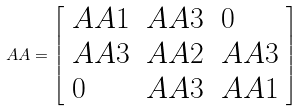<formula> <loc_0><loc_0><loc_500><loc_500>A A = { \left [ \begin{array} { l l l } { A A 1 } & { A A 3 } & { 0 } \\ { A A 3 } & { A A 2 } & { A A 3 } \\ { 0 } & { A A 3 } & { A A 1 } \end{array} \right ] }</formula> 